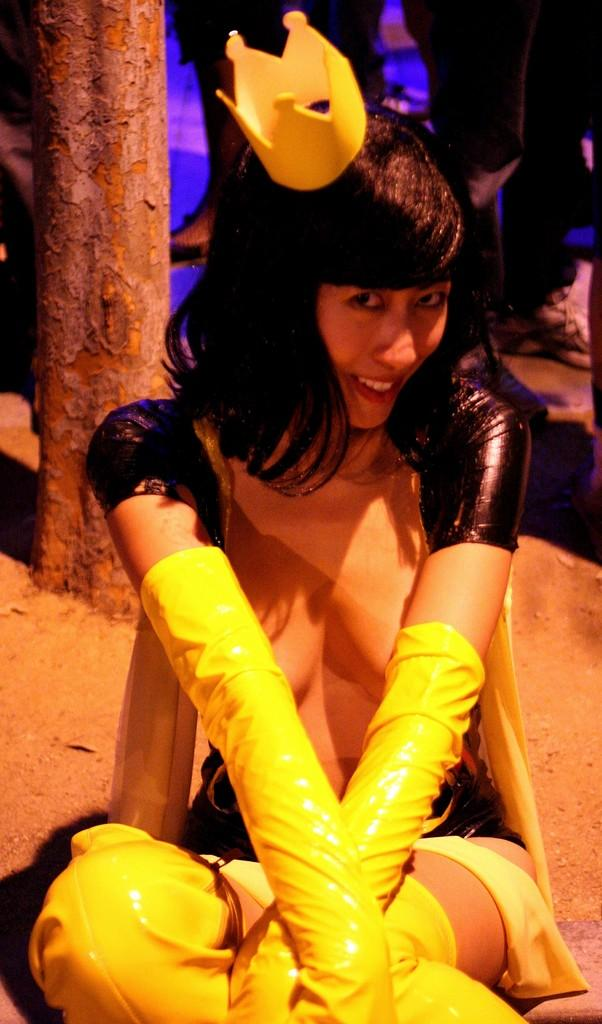What is the woman in the image doing? The woman is sitting in the image. What expression does the woman have? The woman is smiling. What is the woman wearing? The woman is wearing a fancy dress. What can be seen in the foreground of the image? There is a tree trunk in the image. What is visible in the background of the image? There are people standing in the background of the image. What type of crown is the woman wearing on her knee in the image? There is no crown present in the image, nor is there any mention of a knee. 